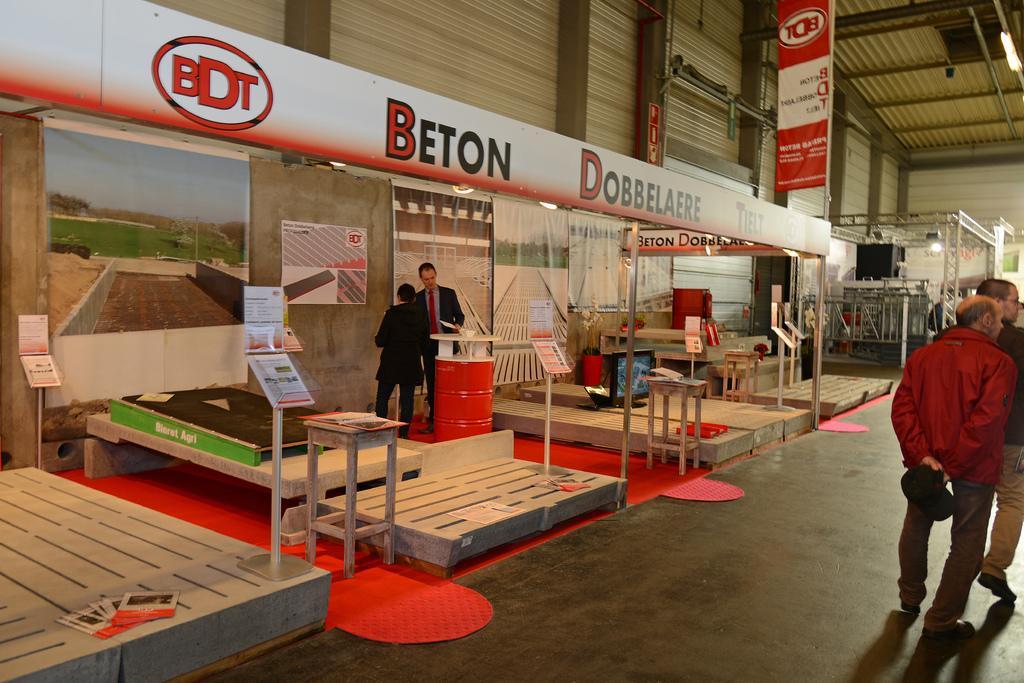Could you give a brief overview of what you see in this image? In this image two person are walking on the floor. A person wearing a red jacket is holding a cap in his hand. A person wearing suit and tie is standing behind the drum. Beside him there is a person standing on the floor. There are few stools and poles having boards are in the stalls. There are few posts attached to the wall. There is a screen on the wooden plank. Top of image a banner is attached to the pole. 